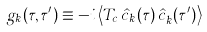<formula> <loc_0><loc_0><loc_500><loc_500>g _ { k } ( \tau , \tau ^ { \prime } ) \equiv - i \left < T _ { c } \, \hat { c } _ { k } ( \tau ) \, \hat { c } _ { k } ^ { \dagger } ( \tau ^ { \prime } ) \right ></formula> 